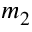<formula> <loc_0><loc_0><loc_500><loc_500>m _ { 2 }</formula> 